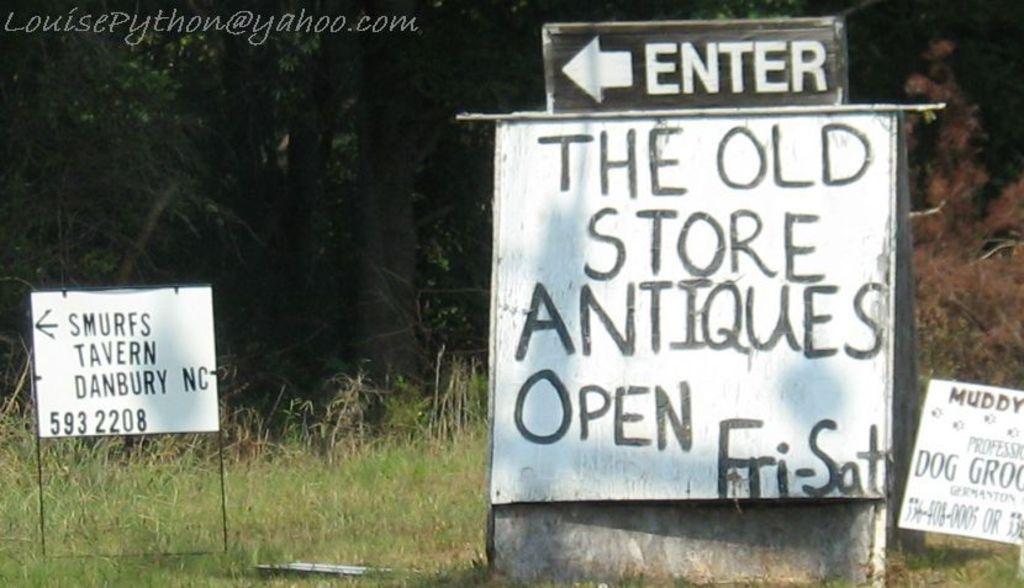Describe this image in one or two sentences. In the center of the image there is a sign board. At the bottom of the image there is grass. To the left side of the image there is another board. In the background of the image there are trees. 